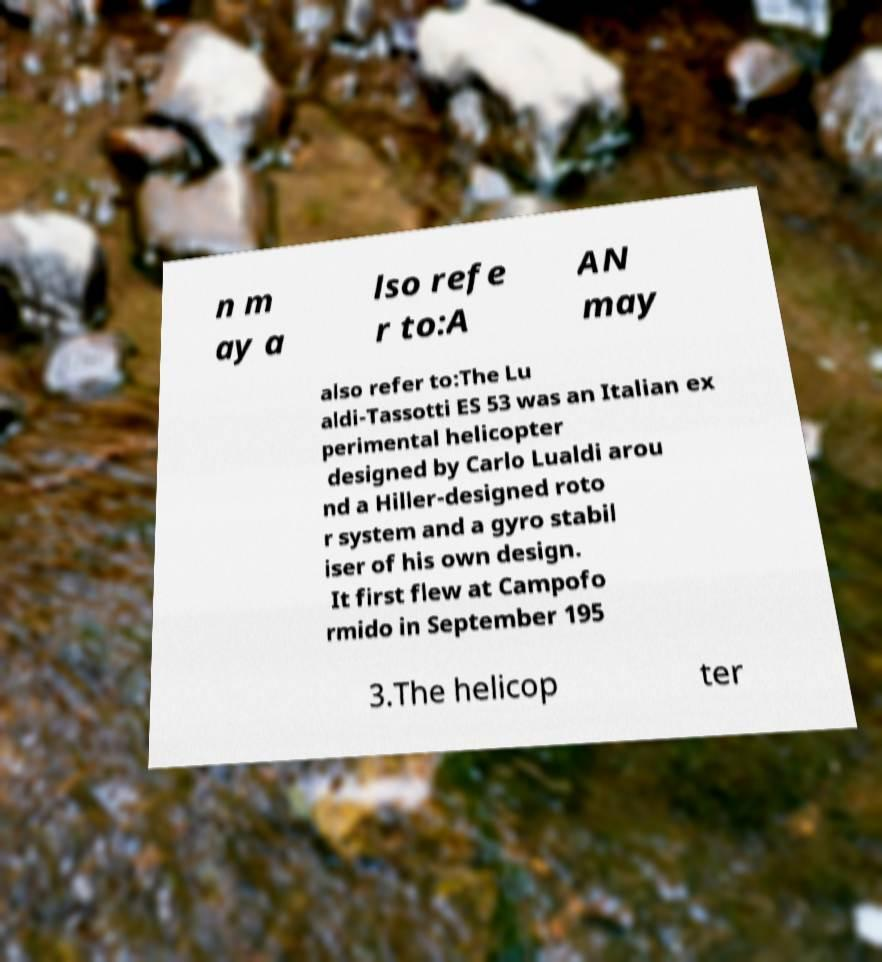There's text embedded in this image that I need extracted. Can you transcribe it verbatim? n m ay a lso refe r to:A AN may also refer to:The Lu aldi-Tassotti ES 53 was an Italian ex perimental helicopter designed by Carlo Lualdi arou nd a Hiller-designed roto r system and a gyro stabil iser of his own design. It first flew at Campofo rmido in September 195 3.The helicop ter 